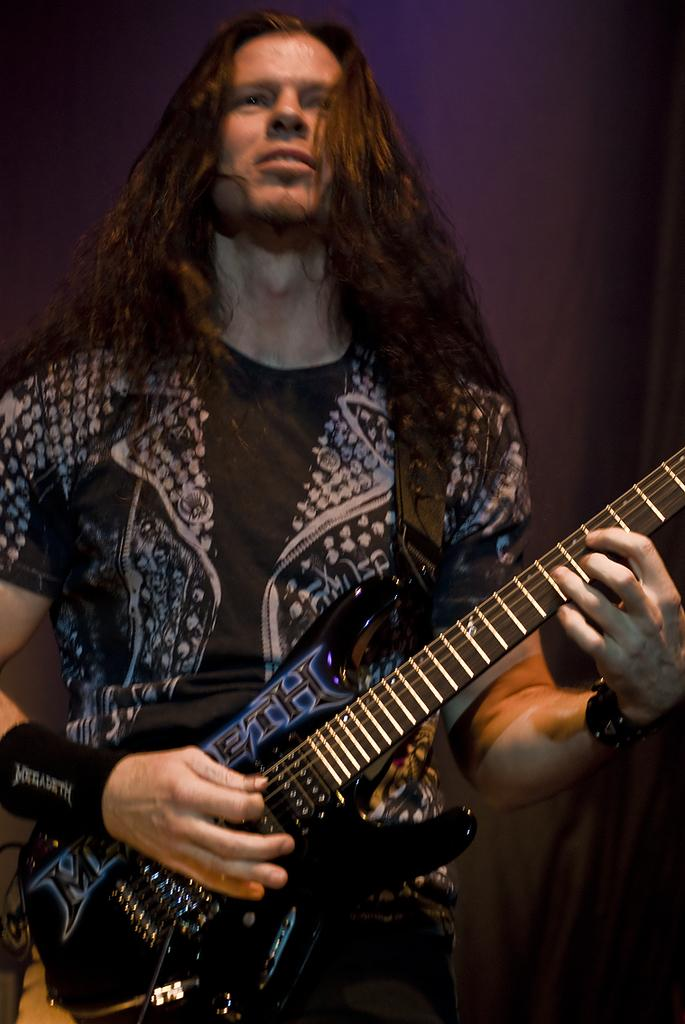Who is the main subject in the image? There is a man in the image. What is the man holding in the image? The man is holding a guitar. What is the man doing with the guitar? The man is playing music with the guitar. What expression does the man have on his face? The man is smiling. What type of nut is the man using to comb his hair in the image? There is no nut or comb present in the image; the man is holding a guitar and playing music. 